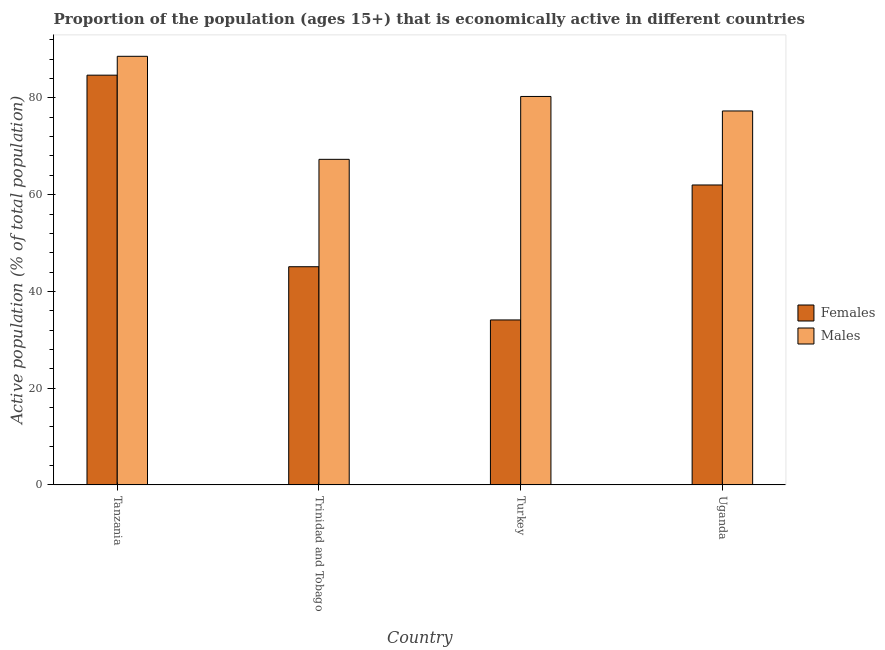How many groups of bars are there?
Provide a succinct answer. 4. How many bars are there on the 4th tick from the right?
Offer a very short reply. 2. What is the label of the 2nd group of bars from the left?
Your answer should be very brief. Trinidad and Tobago. What is the percentage of economically active female population in Turkey?
Provide a succinct answer. 34.1. Across all countries, what is the maximum percentage of economically active male population?
Make the answer very short. 88.6. Across all countries, what is the minimum percentage of economically active male population?
Ensure brevity in your answer.  67.3. In which country was the percentage of economically active female population maximum?
Provide a succinct answer. Tanzania. In which country was the percentage of economically active female population minimum?
Give a very brief answer. Turkey. What is the total percentage of economically active male population in the graph?
Offer a terse response. 313.5. What is the difference between the percentage of economically active female population in Tanzania and that in Uganda?
Keep it short and to the point. 22.7. What is the difference between the percentage of economically active male population in Uganda and the percentage of economically active female population in Tanzania?
Keep it short and to the point. -7.4. What is the average percentage of economically active female population per country?
Give a very brief answer. 56.47. What is the difference between the percentage of economically active male population and percentage of economically active female population in Tanzania?
Provide a succinct answer. 3.9. What is the ratio of the percentage of economically active female population in Turkey to that in Uganda?
Provide a short and direct response. 0.55. Is the percentage of economically active male population in Tanzania less than that in Uganda?
Offer a very short reply. No. Is the difference between the percentage of economically active male population in Turkey and Uganda greater than the difference between the percentage of economically active female population in Turkey and Uganda?
Your answer should be very brief. Yes. What is the difference between the highest and the second highest percentage of economically active female population?
Provide a succinct answer. 22.7. What is the difference between the highest and the lowest percentage of economically active female population?
Keep it short and to the point. 50.6. In how many countries, is the percentage of economically active male population greater than the average percentage of economically active male population taken over all countries?
Your response must be concise. 2. What does the 1st bar from the left in Trinidad and Tobago represents?
Give a very brief answer. Females. What does the 1st bar from the right in Tanzania represents?
Your response must be concise. Males. What is the difference between two consecutive major ticks on the Y-axis?
Your response must be concise. 20. Are the values on the major ticks of Y-axis written in scientific E-notation?
Provide a succinct answer. No. Does the graph contain any zero values?
Your response must be concise. No. Does the graph contain grids?
Give a very brief answer. No. Where does the legend appear in the graph?
Your answer should be very brief. Center right. How many legend labels are there?
Your answer should be very brief. 2. What is the title of the graph?
Provide a succinct answer. Proportion of the population (ages 15+) that is economically active in different countries. Does "Research and Development" appear as one of the legend labels in the graph?
Provide a succinct answer. No. What is the label or title of the X-axis?
Give a very brief answer. Country. What is the label or title of the Y-axis?
Your response must be concise. Active population (% of total population). What is the Active population (% of total population) of Females in Tanzania?
Offer a very short reply. 84.7. What is the Active population (% of total population) in Males in Tanzania?
Offer a very short reply. 88.6. What is the Active population (% of total population) in Females in Trinidad and Tobago?
Provide a succinct answer. 45.1. What is the Active population (% of total population) of Males in Trinidad and Tobago?
Provide a short and direct response. 67.3. What is the Active population (% of total population) of Females in Turkey?
Your answer should be compact. 34.1. What is the Active population (% of total population) of Males in Turkey?
Your answer should be compact. 80.3. What is the Active population (% of total population) of Males in Uganda?
Make the answer very short. 77.3. Across all countries, what is the maximum Active population (% of total population) of Females?
Ensure brevity in your answer.  84.7. Across all countries, what is the maximum Active population (% of total population) of Males?
Provide a succinct answer. 88.6. Across all countries, what is the minimum Active population (% of total population) of Females?
Ensure brevity in your answer.  34.1. Across all countries, what is the minimum Active population (% of total population) of Males?
Keep it short and to the point. 67.3. What is the total Active population (% of total population) in Females in the graph?
Ensure brevity in your answer.  225.9. What is the total Active population (% of total population) of Males in the graph?
Provide a short and direct response. 313.5. What is the difference between the Active population (% of total population) in Females in Tanzania and that in Trinidad and Tobago?
Ensure brevity in your answer.  39.6. What is the difference between the Active population (% of total population) in Males in Tanzania and that in Trinidad and Tobago?
Your answer should be very brief. 21.3. What is the difference between the Active population (% of total population) in Females in Tanzania and that in Turkey?
Offer a terse response. 50.6. What is the difference between the Active population (% of total population) in Males in Tanzania and that in Turkey?
Ensure brevity in your answer.  8.3. What is the difference between the Active population (% of total population) in Females in Tanzania and that in Uganda?
Ensure brevity in your answer.  22.7. What is the difference between the Active population (% of total population) of Males in Tanzania and that in Uganda?
Provide a succinct answer. 11.3. What is the difference between the Active population (% of total population) of Females in Trinidad and Tobago and that in Turkey?
Provide a succinct answer. 11. What is the difference between the Active population (% of total population) of Males in Trinidad and Tobago and that in Turkey?
Make the answer very short. -13. What is the difference between the Active population (% of total population) of Females in Trinidad and Tobago and that in Uganda?
Keep it short and to the point. -16.9. What is the difference between the Active population (% of total population) in Females in Turkey and that in Uganda?
Your answer should be very brief. -27.9. What is the difference between the Active population (% of total population) in Males in Turkey and that in Uganda?
Your response must be concise. 3. What is the difference between the Active population (% of total population) in Females in Tanzania and the Active population (% of total population) in Males in Trinidad and Tobago?
Provide a succinct answer. 17.4. What is the difference between the Active population (% of total population) of Females in Trinidad and Tobago and the Active population (% of total population) of Males in Turkey?
Ensure brevity in your answer.  -35.2. What is the difference between the Active population (% of total population) in Females in Trinidad and Tobago and the Active population (% of total population) in Males in Uganda?
Offer a terse response. -32.2. What is the difference between the Active population (% of total population) in Females in Turkey and the Active population (% of total population) in Males in Uganda?
Ensure brevity in your answer.  -43.2. What is the average Active population (% of total population) of Females per country?
Your answer should be very brief. 56.48. What is the average Active population (% of total population) of Males per country?
Provide a succinct answer. 78.38. What is the difference between the Active population (% of total population) in Females and Active population (% of total population) in Males in Trinidad and Tobago?
Keep it short and to the point. -22.2. What is the difference between the Active population (% of total population) of Females and Active population (% of total population) of Males in Turkey?
Your response must be concise. -46.2. What is the difference between the Active population (% of total population) in Females and Active population (% of total population) in Males in Uganda?
Your answer should be very brief. -15.3. What is the ratio of the Active population (% of total population) in Females in Tanzania to that in Trinidad and Tobago?
Your answer should be compact. 1.88. What is the ratio of the Active population (% of total population) in Males in Tanzania to that in Trinidad and Tobago?
Keep it short and to the point. 1.32. What is the ratio of the Active population (% of total population) in Females in Tanzania to that in Turkey?
Give a very brief answer. 2.48. What is the ratio of the Active population (% of total population) in Males in Tanzania to that in Turkey?
Your response must be concise. 1.1. What is the ratio of the Active population (% of total population) in Females in Tanzania to that in Uganda?
Make the answer very short. 1.37. What is the ratio of the Active population (% of total population) of Males in Tanzania to that in Uganda?
Keep it short and to the point. 1.15. What is the ratio of the Active population (% of total population) of Females in Trinidad and Tobago to that in Turkey?
Provide a succinct answer. 1.32. What is the ratio of the Active population (% of total population) in Males in Trinidad and Tobago to that in Turkey?
Give a very brief answer. 0.84. What is the ratio of the Active population (% of total population) in Females in Trinidad and Tobago to that in Uganda?
Make the answer very short. 0.73. What is the ratio of the Active population (% of total population) in Males in Trinidad and Tobago to that in Uganda?
Your response must be concise. 0.87. What is the ratio of the Active population (% of total population) in Females in Turkey to that in Uganda?
Your answer should be compact. 0.55. What is the ratio of the Active population (% of total population) of Males in Turkey to that in Uganda?
Give a very brief answer. 1.04. What is the difference between the highest and the second highest Active population (% of total population) in Females?
Keep it short and to the point. 22.7. What is the difference between the highest and the second highest Active population (% of total population) of Males?
Your answer should be very brief. 8.3. What is the difference between the highest and the lowest Active population (% of total population) in Females?
Keep it short and to the point. 50.6. What is the difference between the highest and the lowest Active population (% of total population) in Males?
Ensure brevity in your answer.  21.3. 